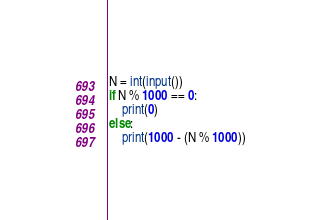Convert code to text. <code><loc_0><loc_0><loc_500><loc_500><_Python_>N = int(input())
if N % 1000 == 0:
    print(0)
else:
    print(1000 - (N % 1000))
</code> 